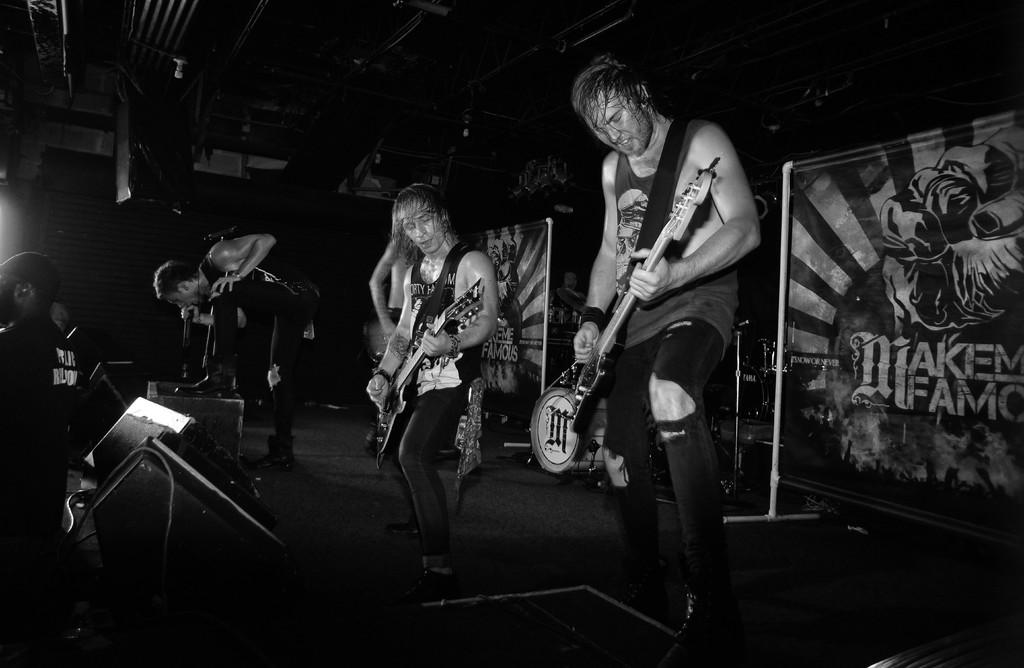How many people are in the image? There are two persons in the image. What are the persons doing in the image? Both persons are playing guitars. Can you describe the posture of one of the persons? One person is bending. What can be seen in the background of the image? There is a board visible in the background. How many bikes are parked next to the persons in the image? There are no bikes present in the image. Is there a volcano visible in the background of the image? No, there is no volcano visible in the image; only a board can be seen in the background. 